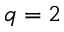<formula> <loc_0><loc_0><loc_500><loc_500>q = 2</formula> 